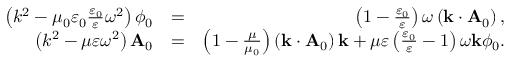Convert formula to latex. <formula><loc_0><loc_0><loc_500><loc_500>\begin{array} { r l r } { \left ( k ^ { 2 } - \mu _ { 0 } \varepsilon _ { 0 } \frac { \varepsilon _ { 0 } } { \varepsilon } \omega ^ { 2 } \right ) \phi _ { 0 } } & { = } & { \left ( 1 - \frac { \varepsilon _ { 0 } } { \varepsilon } \right ) \omega \left ( k \cdot A _ { 0 } \right ) , } \\ { \left ( k ^ { 2 } - \mu \varepsilon \omega ^ { 2 } \right ) A _ { 0 } } & { = } & { \left ( 1 - \frac { \mu } { \mu _ { 0 } } \right ) \left ( k \cdot A _ { 0 } \right ) k + \mu \varepsilon \left ( \frac { \varepsilon _ { 0 } } { \varepsilon } - 1 \right ) \omega k \phi _ { 0 } . } \end{array}</formula> 